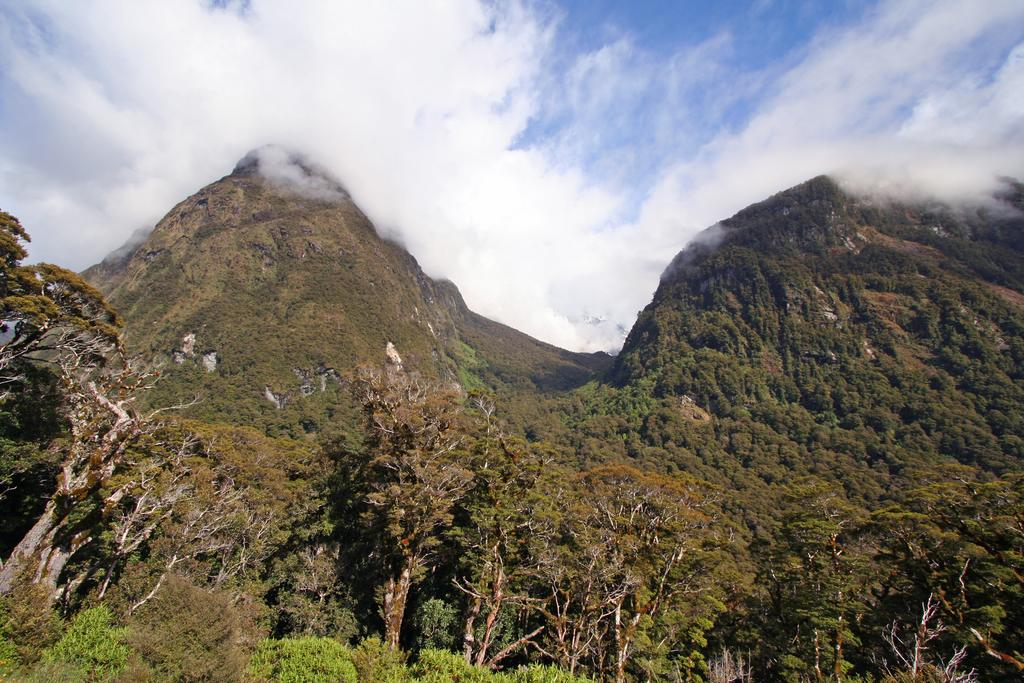What type of vegetation is at the bottom of the image? There are trees at the bottom of the image. What geographical features can be seen in the middle of the image? There are hills in the middle of the image. What is visible at the top of the image? The sky is visible at the top of the image. Where is the net located in the image? There is no net present in the image. What type of juice can be seen flowing down the mountain in the image? There is no mountain or juice present in the image. 